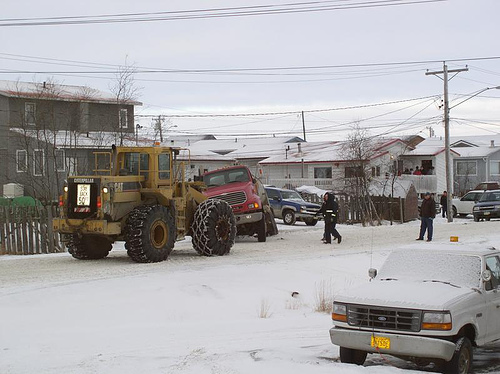<image>
Is the car in front of the building? Yes. The car is positioned in front of the building, appearing closer to the camera viewpoint. 